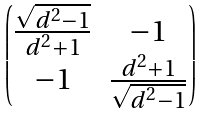<formula> <loc_0><loc_0><loc_500><loc_500>\begin{pmatrix} \frac { \sqrt { d ^ { 2 } - 1 } } { d ^ { 2 } + 1 } & - 1 \\ - 1 & \frac { d ^ { 2 } + 1 } { \sqrt { d ^ { 2 } - 1 } } \end{pmatrix}</formula> 